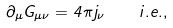Convert formula to latex. <formula><loc_0><loc_0><loc_500><loc_500>\partial _ { \mu } G _ { \mu \nu } = 4 \pi j _ { \nu } \quad i . e . ,</formula> 